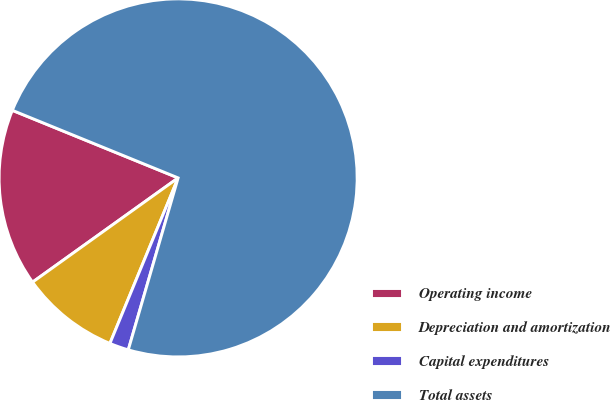Convert chart. <chart><loc_0><loc_0><loc_500><loc_500><pie_chart><fcel>Operating income<fcel>Depreciation and amortization<fcel>Capital expenditures<fcel>Total assets<nl><fcel>16.05%<fcel>8.89%<fcel>1.73%<fcel>73.33%<nl></chart> 